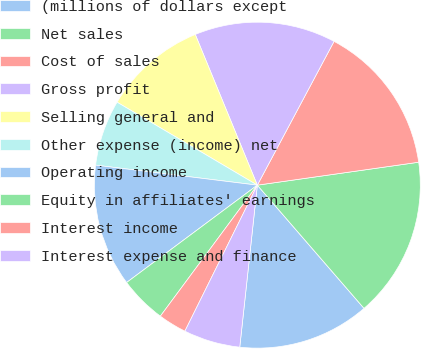<chart> <loc_0><loc_0><loc_500><loc_500><pie_chart><fcel>(millions of dollars except<fcel>Net sales<fcel>Cost of sales<fcel>Gross profit<fcel>Selling general and<fcel>Other expense (income) net<fcel>Operating income<fcel>Equity in affiliates' earnings<fcel>Interest income<fcel>Interest expense and finance<nl><fcel>13.08%<fcel>15.89%<fcel>14.95%<fcel>14.02%<fcel>10.28%<fcel>6.54%<fcel>12.15%<fcel>4.67%<fcel>2.81%<fcel>5.61%<nl></chart> 